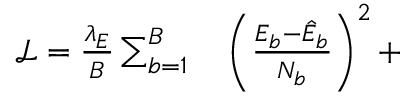Convert formula to latex. <formula><loc_0><loc_0><loc_500><loc_500>\begin{array} { r l } { \mathcal { L } = \frac { \lambda _ { E } } { B } \sum _ { b = 1 } ^ { B } } & \left ( \frac { E _ { b } - \hat { E } _ { b } } { N _ { b } } \right ) ^ { 2 } + } \end{array}</formula> 